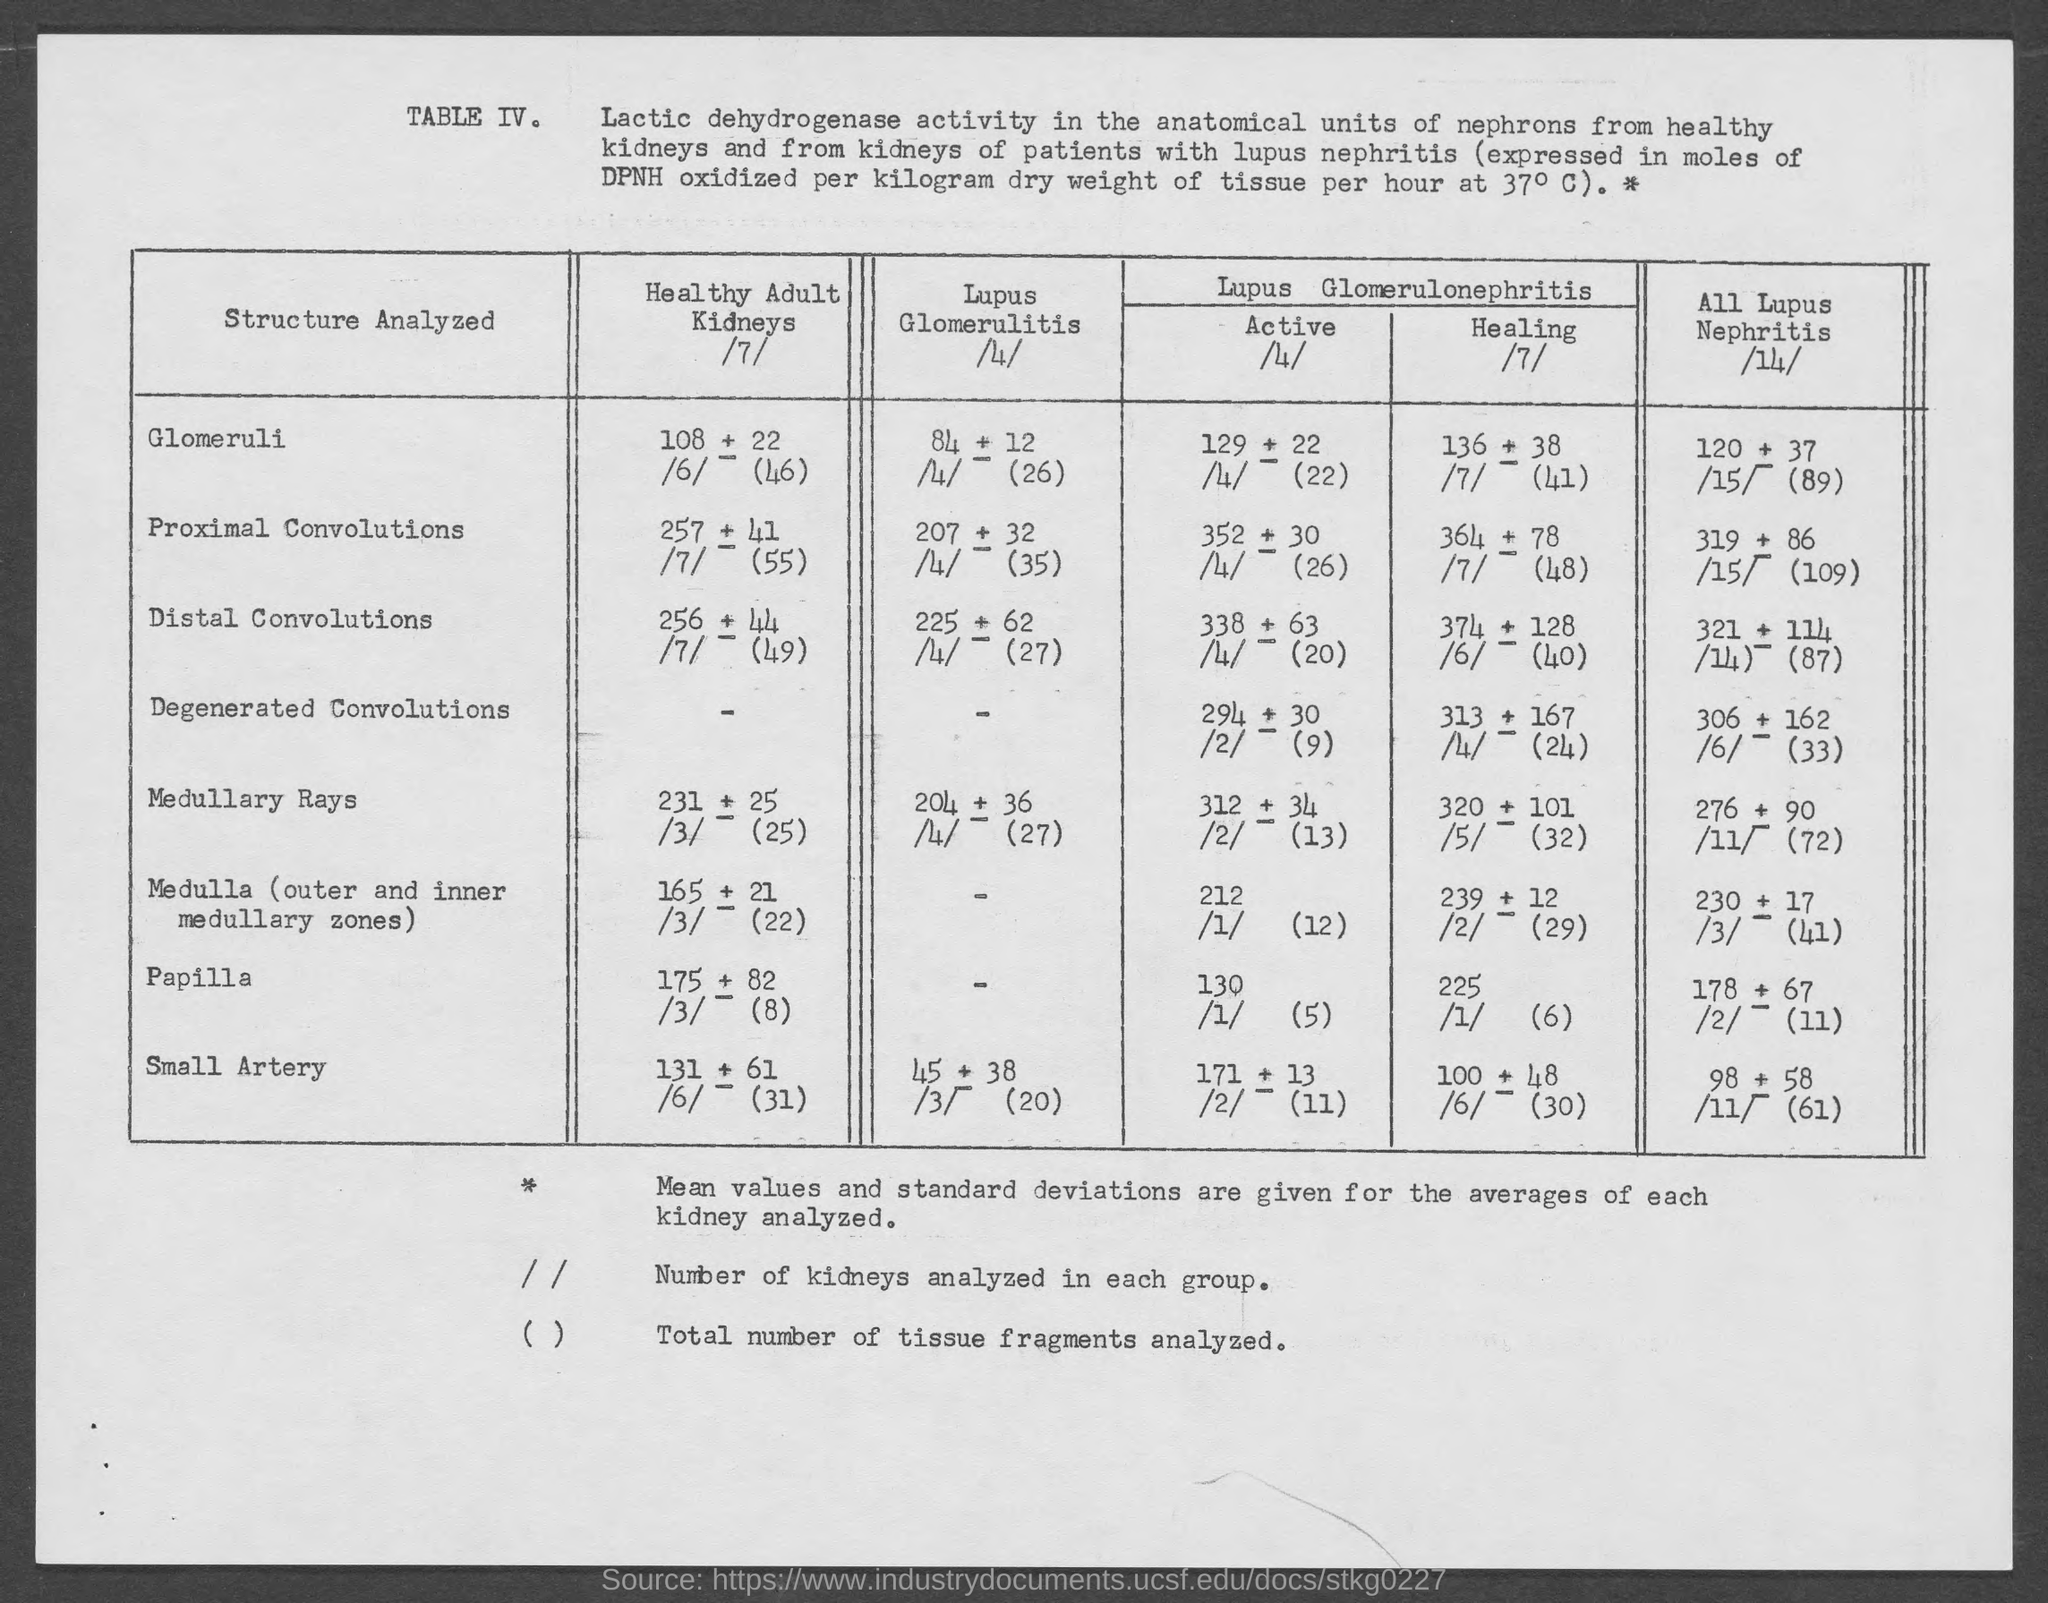What is the table no.?
Your response must be concise. Table iv. 